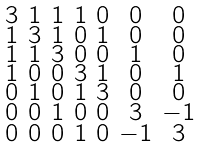<formula> <loc_0><loc_0><loc_500><loc_500>\begin{smallmatrix} 3 & 1 & 1 & 1 & 0 & 0 & 0 \\ 1 & 3 & 1 & 0 & 1 & 0 & 0 \\ 1 & 1 & 3 & 0 & 0 & 1 & 0 \\ 1 & 0 & 0 & 3 & 1 & 0 & 1 \\ 0 & 1 & 0 & 1 & 3 & 0 & 0 \\ 0 & 0 & 1 & 0 & 0 & 3 & - 1 \\ 0 & 0 & 0 & 1 & 0 & - 1 & 3 \end{smallmatrix}</formula> 